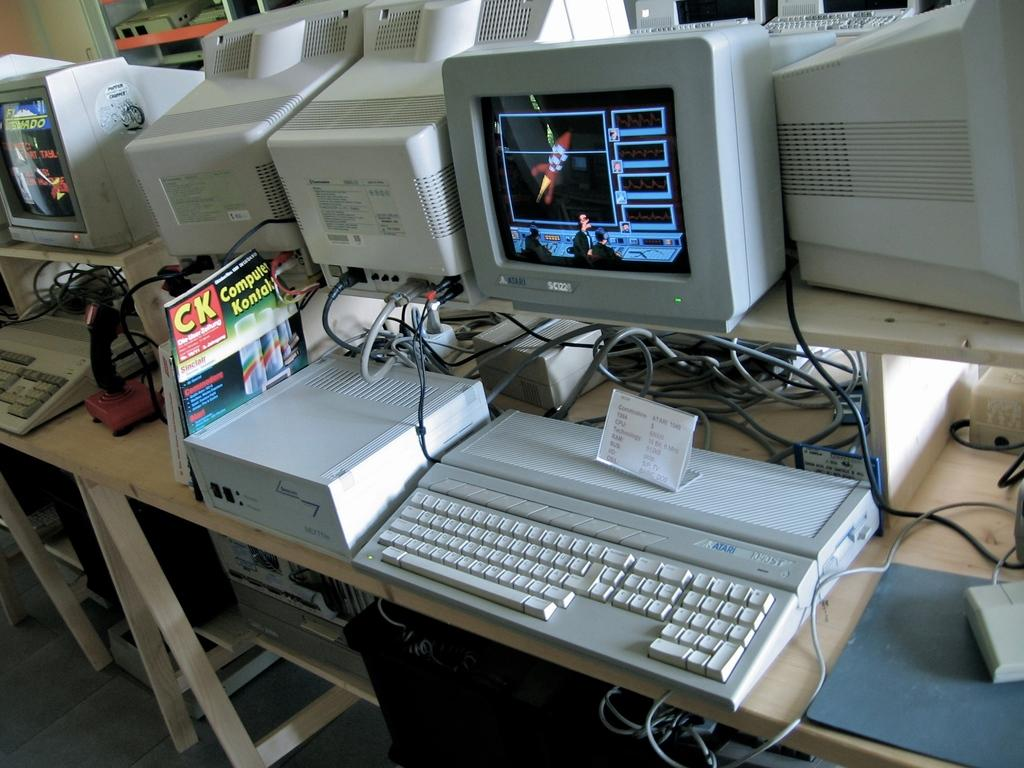What electronic device is present in the image? There is a monitor in the image. What is used for input with the monitor? There is a keyboard in the image. What connects the devices in the image? There are wires visible in the image. What piece of furniture is the monitor and keyboard placed on? There is a table in the image. What additional item can be seen on the table? There is a book in the image. What type of apparel is being worn by the monitor in the image? Monitors do not wear apparel; they are electronic devices. Can you describe the flavor of the pie in the image? There is no pie present in the image. 